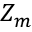Convert formula to latex. <formula><loc_0><loc_0><loc_500><loc_500>Z _ { m }</formula> 